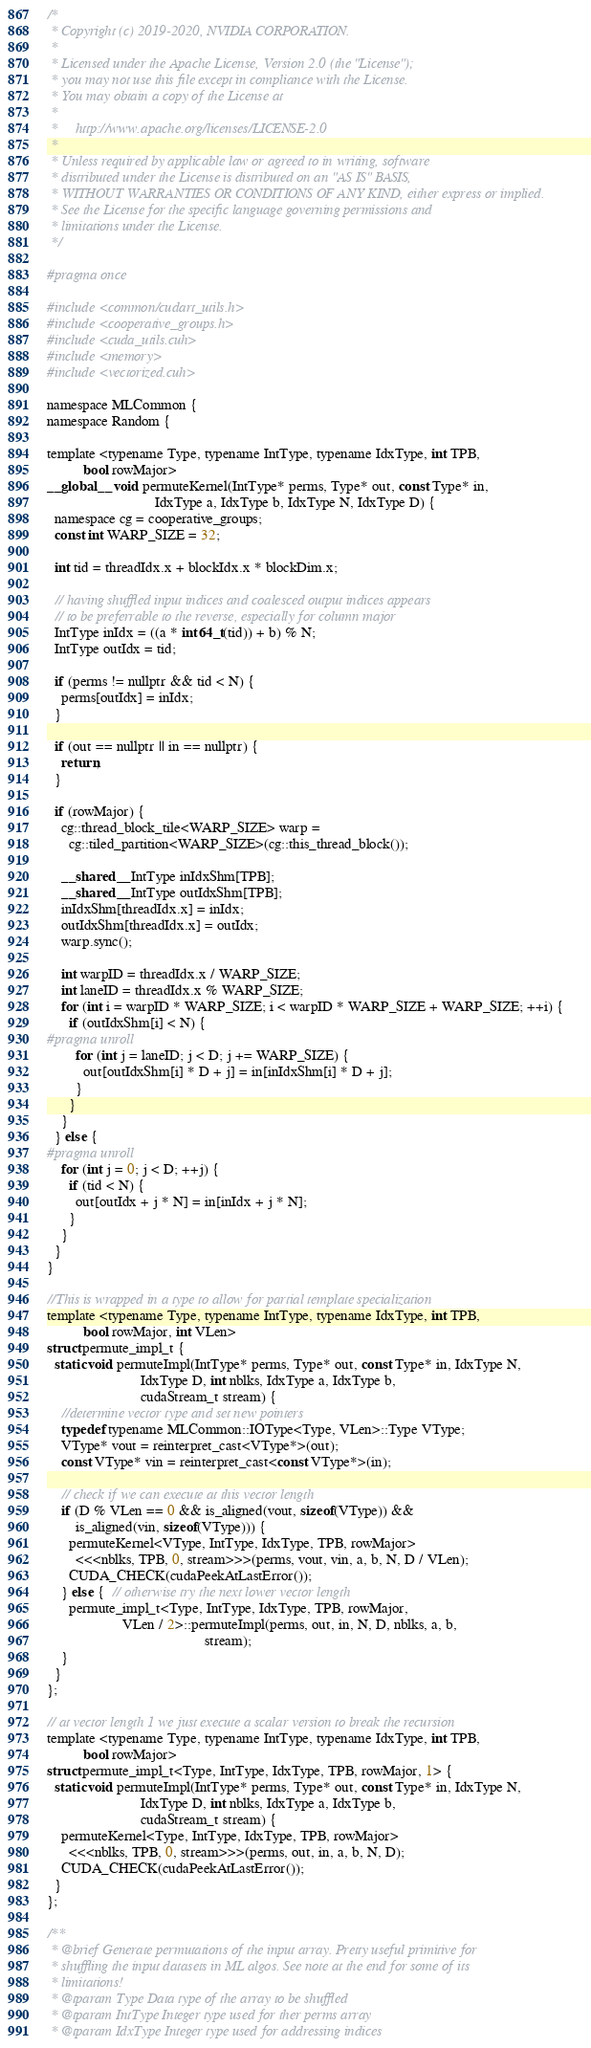<code> <loc_0><loc_0><loc_500><loc_500><_Cuda_>/*
 * Copyright (c) 2019-2020, NVIDIA CORPORATION.
 *
 * Licensed under the Apache License, Version 2.0 (the "License");
 * you may not use this file except in compliance with the License.
 * You may obtain a copy of the License at
 *
 *     http://www.apache.org/licenses/LICENSE-2.0
 *
 * Unless required by applicable law or agreed to in writing, software
 * distributed under the License is distributed on an "AS IS" BASIS,
 * WITHOUT WARRANTIES OR CONDITIONS OF ANY KIND, either express or implied.
 * See the License for the specific language governing permissions and
 * limitations under the License.
 */

#pragma once

#include <common/cudart_utils.h>
#include <cooperative_groups.h>
#include <cuda_utils.cuh>
#include <memory>
#include <vectorized.cuh>

namespace MLCommon {
namespace Random {

template <typename Type, typename IntType, typename IdxType, int TPB,
          bool rowMajor>
__global__ void permuteKernel(IntType* perms, Type* out, const Type* in,
                              IdxType a, IdxType b, IdxType N, IdxType D) {
  namespace cg = cooperative_groups;
  const int WARP_SIZE = 32;

  int tid = threadIdx.x + blockIdx.x * blockDim.x;

  // having shuffled input indices and coalesced output indices appears
  // to be preferrable to the reverse, especially for column major
  IntType inIdx = ((a * int64_t(tid)) + b) % N;
  IntType outIdx = tid;

  if (perms != nullptr && tid < N) {
    perms[outIdx] = inIdx;
  }

  if (out == nullptr || in == nullptr) {
    return;
  }

  if (rowMajor) {
    cg::thread_block_tile<WARP_SIZE> warp =
      cg::tiled_partition<WARP_SIZE>(cg::this_thread_block());

    __shared__ IntType inIdxShm[TPB];
    __shared__ IntType outIdxShm[TPB];
    inIdxShm[threadIdx.x] = inIdx;
    outIdxShm[threadIdx.x] = outIdx;
    warp.sync();

    int warpID = threadIdx.x / WARP_SIZE;
    int laneID = threadIdx.x % WARP_SIZE;
    for (int i = warpID * WARP_SIZE; i < warpID * WARP_SIZE + WARP_SIZE; ++i) {
      if (outIdxShm[i] < N) {
#pragma unroll
        for (int j = laneID; j < D; j += WARP_SIZE) {
          out[outIdxShm[i] * D + j] = in[inIdxShm[i] * D + j];
        }
      }
    }
  } else {
#pragma unroll
    for (int j = 0; j < D; ++j) {
      if (tid < N) {
        out[outIdx + j * N] = in[inIdx + j * N];
      }
    }
  }
}

//This is wrapped in a type to allow for partial template specialization
template <typename Type, typename IntType, typename IdxType, int TPB,
          bool rowMajor, int VLen>
struct permute_impl_t {
  static void permuteImpl(IntType* perms, Type* out, const Type* in, IdxType N,
                          IdxType D, int nblks, IdxType a, IdxType b,
                          cudaStream_t stream) {
    //determine vector type and set new pointers
    typedef typename MLCommon::IOType<Type, VLen>::Type VType;
    VType* vout = reinterpret_cast<VType*>(out);
    const VType* vin = reinterpret_cast<const VType*>(in);

    // check if we can execute at this vector length
    if (D % VLen == 0 && is_aligned(vout, sizeof(VType)) &&
        is_aligned(vin, sizeof(VType))) {
      permuteKernel<VType, IntType, IdxType, TPB, rowMajor>
        <<<nblks, TPB, 0, stream>>>(perms, vout, vin, a, b, N, D / VLen);
      CUDA_CHECK(cudaPeekAtLastError());
    } else {  // otherwise try the next lower vector length
      permute_impl_t<Type, IntType, IdxType, TPB, rowMajor,
                     VLen / 2>::permuteImpl(perms, out, in, N, D, nblks, a, b,
                                            stream);
    }
  }
};

// at vector length 1 we just execute a scalar version to break the recursion
template <typename Type, typename IntType, typename IdxType, int TPB,
          bool rowMajor>
struct permute_impl_t<Type, IntType, IdxType, TPB, rowMajor, 1> {
  static void permuteImpl(IntType* perms, Type* out, const Type* in, IdxType N,
                          IdxType D, int nblks, IdxType a, IdxType b,
                          cudaStream_t stream) {
    permuteKernel<Type, IntType, IdxType, TPB, rowMajor>
      <<<nblks, TPB, 0, stream>>>(perms, out, in, a, b, N, D);
    CUDA_CHECK(cudaPeekAtLastError());
  }
};

/**
 * @brief Generate permutations of the input array. Pretty useful primitive for
 * shuffling the input datasets in ML algos. See note at the end for some of its
 * limitations!
 * @tparam Type Data type of the array to be shuffled
 * @tparam IntType Integer type used for ther perms array
 * @tparam IdxType Integer type used for addressing indices</code> 